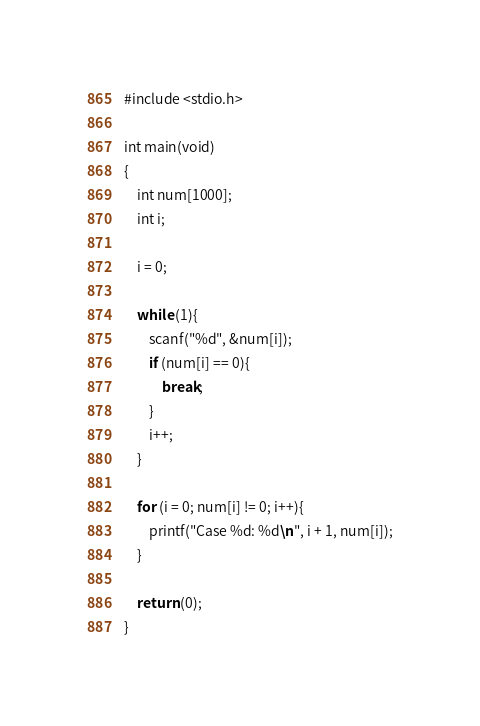<code> <loc_0><loc_0><loc_500><loc_500><_C_>#include <stdio.h>

int main(void)
{
	int num[1000];
	int i;
	
	i = 0;
	
	while (1){
		scanf("%d", &num[i]);
		if (num[i] == 0){
			break;
		}
		i++;
	}
	
	for (i = 0; num[i] != 0; i++){
		printf("Case %d: %d\n", i + 1, num[i]);
	}
	
	return (0);
}</code> 